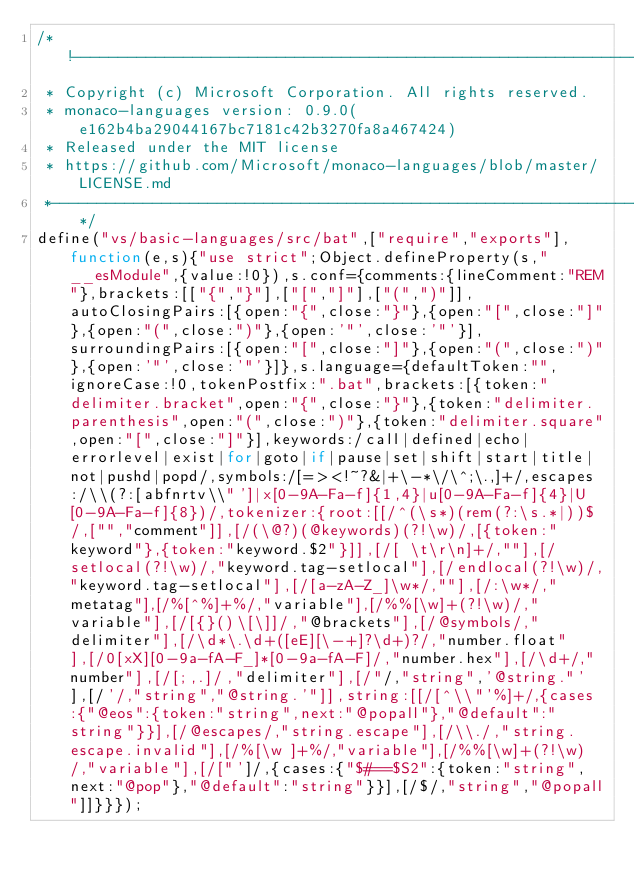Convert code to text. <code><loc_0><loc_0><loc_500><loc_500><_JavaScript_>/*!-----------------------------------------------------------------------------
 * Copyright (c) Microsoft Corporation. All rights reserved.
 * monaco-languages version: 0.9.0(e162b4ba29044167bc7181c42b3270fa8a467424)
 * Released under the MIT license
 * https://github.com/Microsoft/monaco-languages/blob/master/LICENSE.md
 *-----------------------------------------------------------------------------*/
define("vs/basic-languages/src/bat",["require","exports"],function(e,s){"use strict";Object.defineProperty(s,"__esModule",{value:!0}),s.conf={comments:{lineComment:"REM"},brackets:[["{","}"],["[","]"],["(",")"]],autoClosingPairs:[{open:"{",close:"}"},{open:"[",close:"]"},{open:"(",close:")"},{open:'"',close:'"'}],surroundingPairs:[{open:"[",close:"]"},{open:"(",close:")"},{open:'"',close:'"'}]},s.language={defaultToken:"",ignoreCase:!0,tokenPostfix:".bat",brackets:[{token:"delimiter.bracket",open:"{",close:"}"},{token:"delimiter.parenthesis",open:"(",close:")"},{token:"delimiter.square",open:"[",close:"]"}],keywords:/call|defined|echo|errorlevel|exist|for|goto|if|pause|set|shift|start|title|not|pushd|popd/,symbols:/[=><!~?&|+\-*\/\^;\.,]+/,escapes:/\\(?:[abfnrtv\\"']|x[0-9A-Fa-f]{1,4}|u[0-9A-Fa-f]{4}|U[0-9A-Fa-f]{8})/,tokenizer:{root:[[/^(\s*)(rem(?:\s.*|))$/,["","comment"]],[/(\@?)(@keywords)(?!\w)/,[{token:"keyword"},{token:"keyword.$2"}]],[/[ \t\r\n]+/,""],[/setlocal(?!\w)/,"keyword.tag-setlocal"],[/endlocal(?!\w)/,"keyword.tag-setlocal"],[/[a-zA-Z_]\w*/,""],[/:\w*/,"metatag"],[/%[^%]+%/,"variable"],[/%%[\w]+(?!\w)/,"variable"],[/[{}()\[\]]/,"@brackets"],[/@symbols/,"delimiter"],[/\d*\.\d+([eE][\-+]?\d+)?/,"number.float"],[/0[xX][0-9a-fA-F_]*[0-9a-fA-F]/,"number.hex"],[/\d+/,"number"],[/[;,.]/,"delimiter"],[/"/,"string",'@string."'],[/'/,"string","@string.'"]],string:[[/[^\\"'%]+/,{cases:{"@eos":{token:"string",next:"@popall"},"@default":"string"}}],[/@escapes/,"string.escape"],[/\\./,"string.escape.invalid"],[/%[\w ]+%/,"variable"],[/%%[\w]+(?!\w)/,"variable"],[/["']/,{cases:{"$#==$S2":{token:"string",next:"@pop"},"@default":"string"}}],[/$/,"string","@popall"]]}}});</code> 